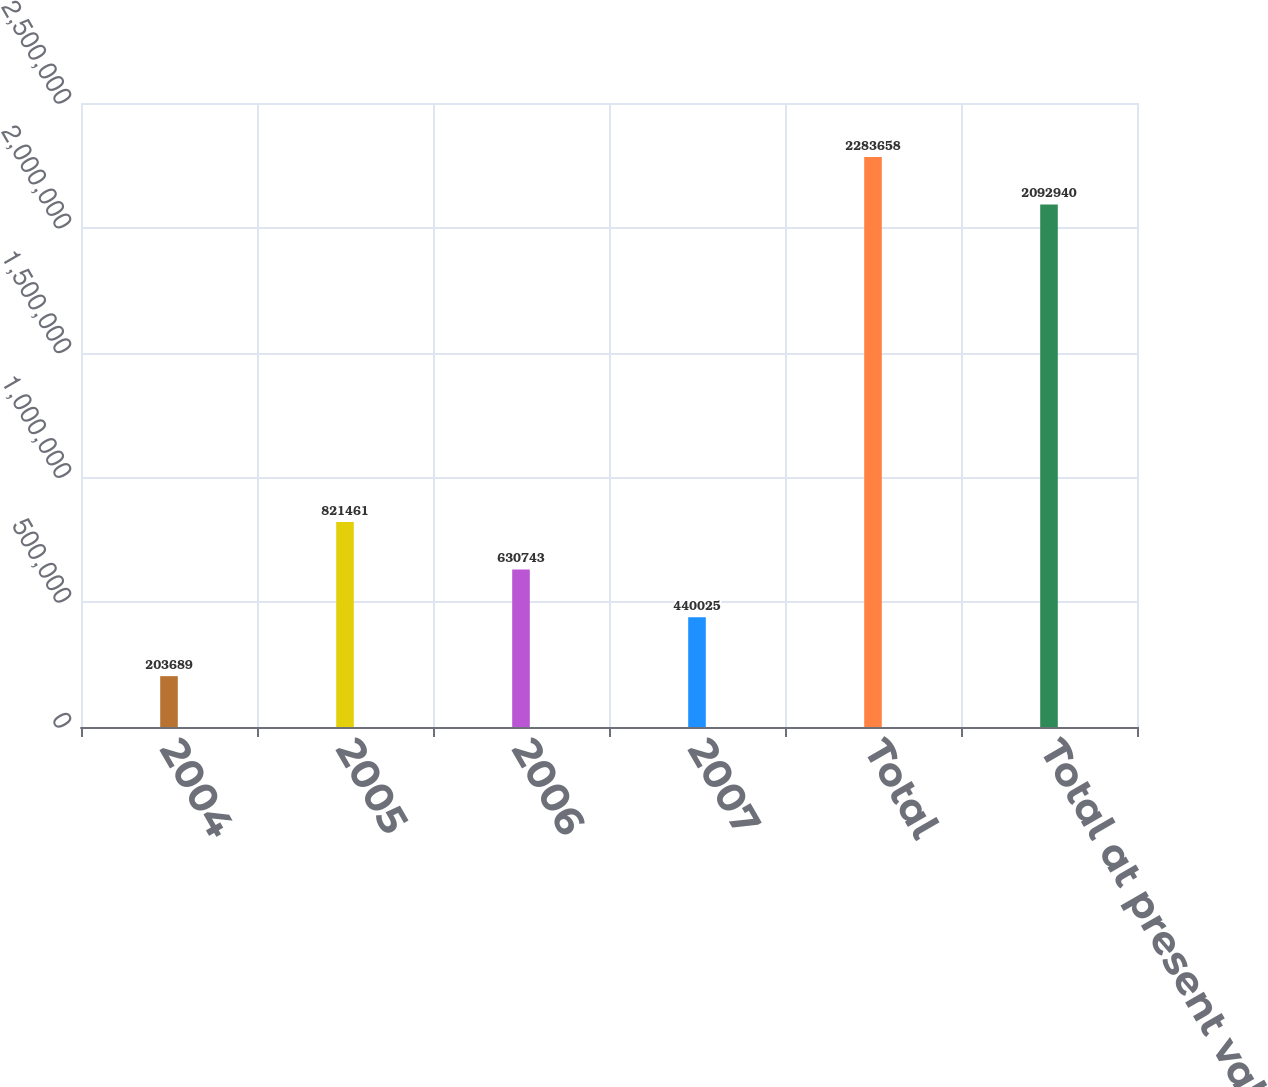Convert chart to OTSL. <chart><loc_0><loc_0><loc_500><loc_500><bar_chart><fcel>2004<fcel>2005<fcel>2006<fcel>2007<fcel>Total<fcel>Total at present value<nl><fcel>203689<fcel>821461<fcel>630743<fcel>440025<fcel>2.28366e+06<fcel>2.09294e+06<nl></chart> 